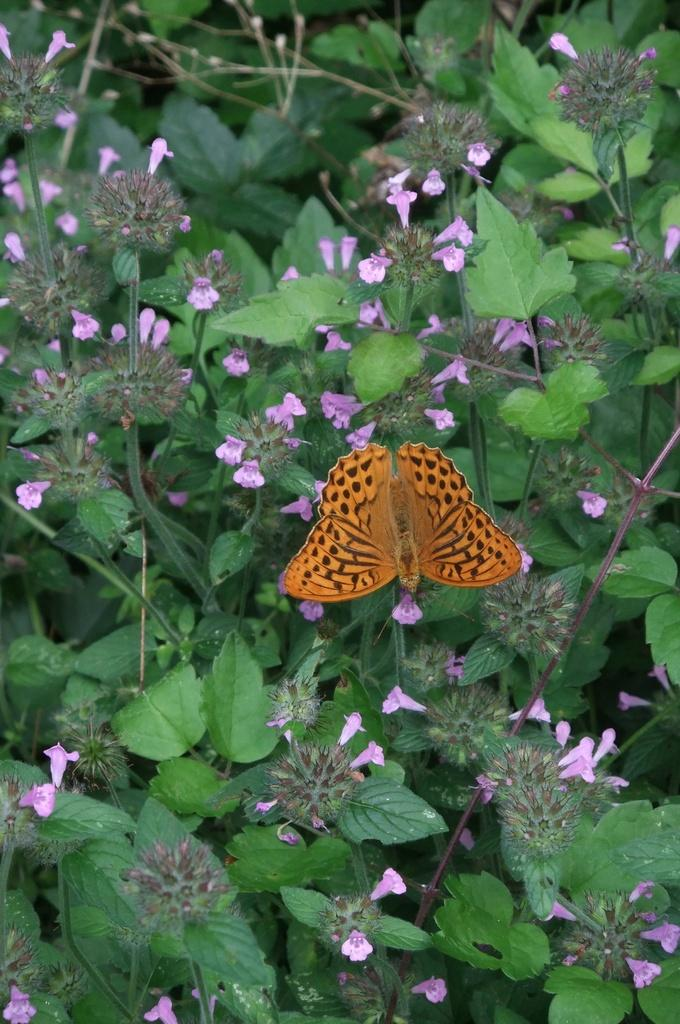What type of insect can be seen in the image? There is a butterfly in the image. What other natural elements are present in the image? There are flowers and green leaves in the image. What level of math can be solved using the calculator in the image? There is no calculator present in the image, so it is not possible to determine the level of math that could be solved. 